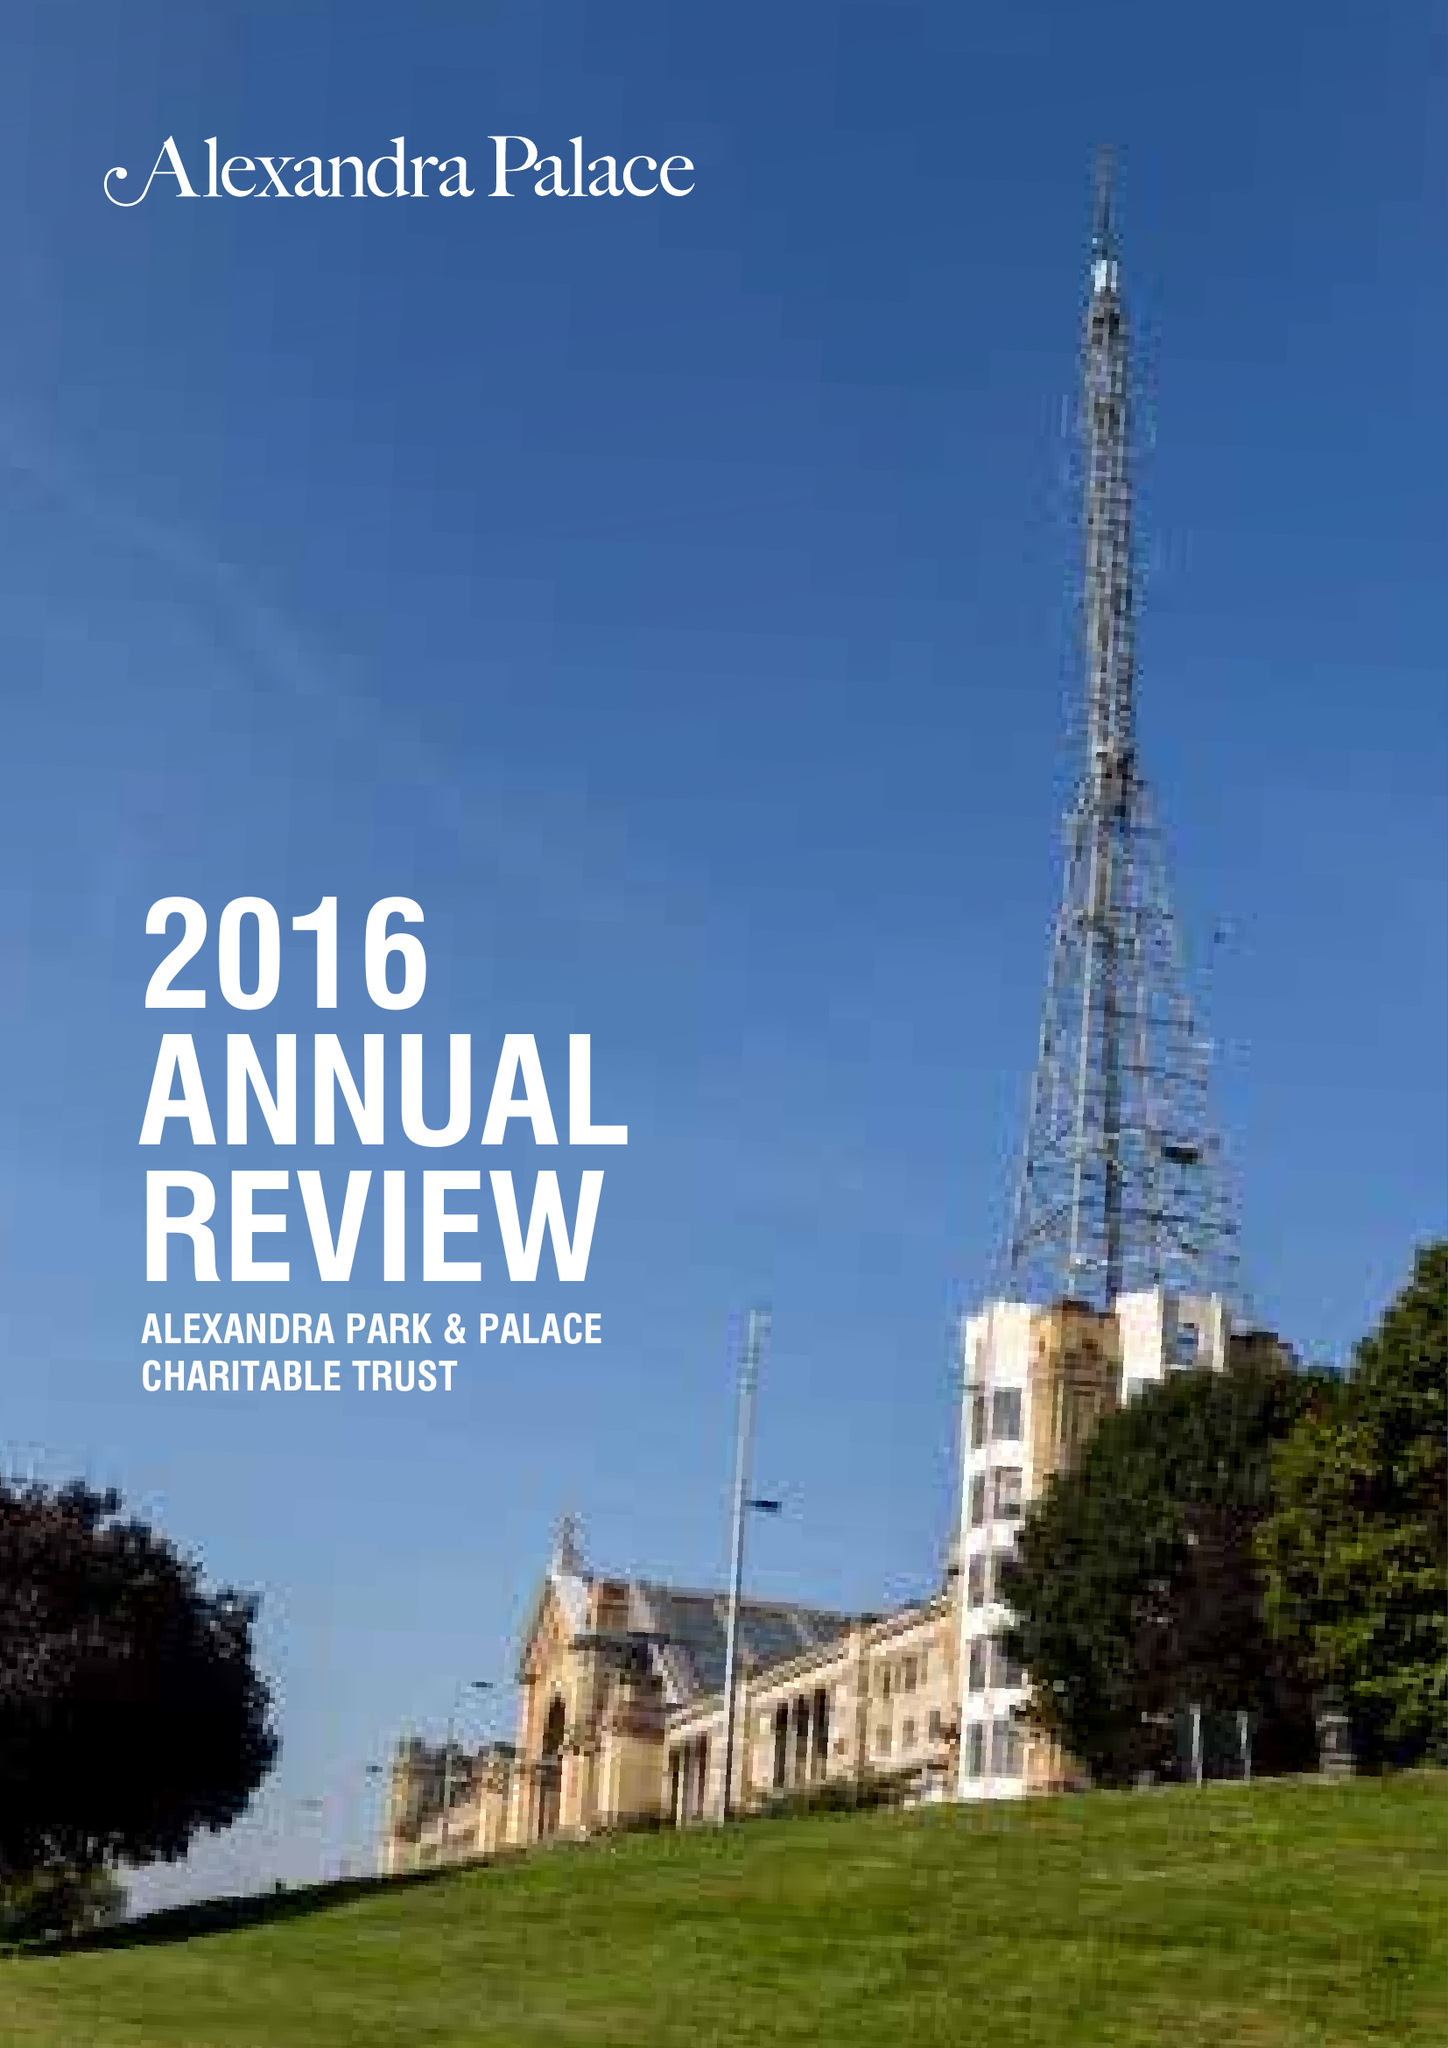What is the value for the report_date?
Answer the question using a single word or phrase. 2016-03-31 